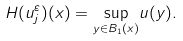<formula> <loc_0><loc_0><loc_500><loc_500>H ( u _ { j } ^ { \varepsilon } ) ( x ) = \underset { y \in B _ { 1 } ( x ) } { \sup } u ( y ) .</formula> 